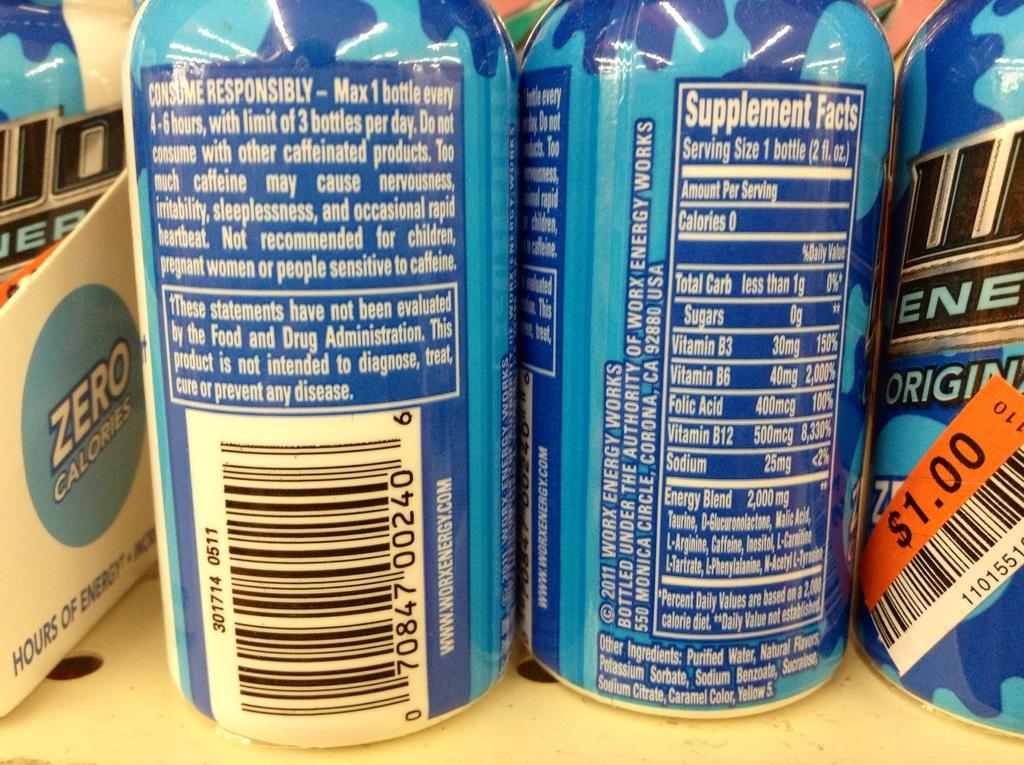<image>
Summarize the visual content of the image. The back of a blue can says consume responsibly. 